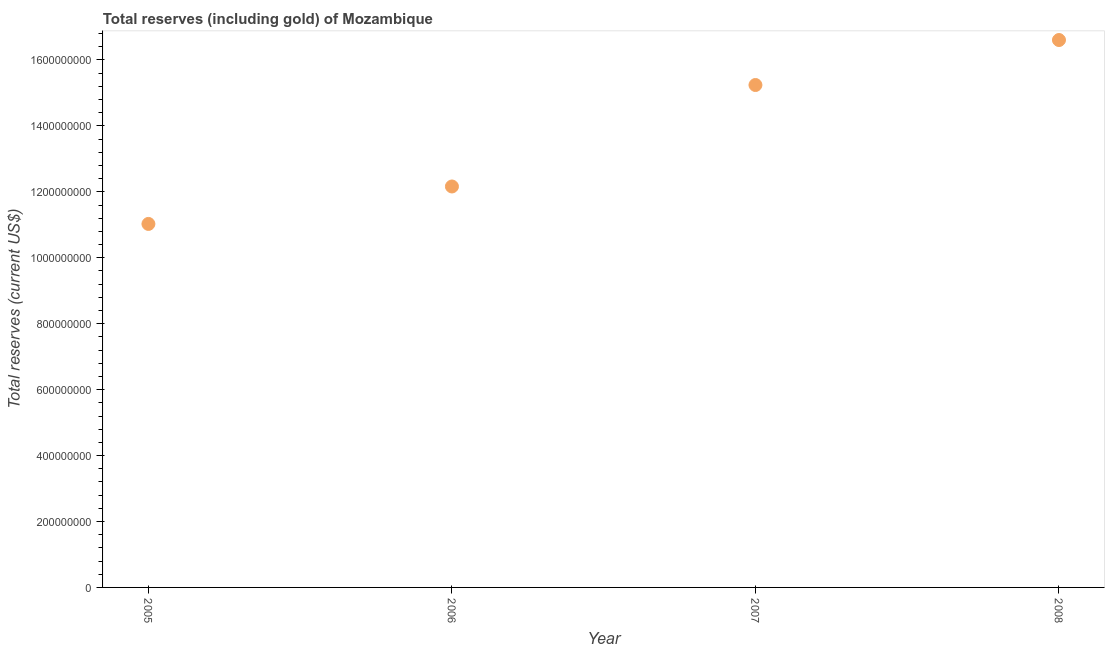What is the total reserves (including gold) in 2005?
Offer a very short reply. 1.10e+09. Across all years, what is the maximum total reserves (including gold)?
Your answer should be compact. 1.66e+09. Across all years, what is the minimum total reserves (including gold)?
Your answer should be compact. 1.10e+09. What is the sum of the total reserves (including gold)?
Provide a short and direct response. 5.50e+09. What is the difference between the total reserves (including gold) in 2005 and 2007?
Offer a terse response. -4.21e+08. What is the average total reserves (including gold) per year?
Your response must be concise. 1.38e+09. What is the median total reserves (including gold)?
Keep it short and to the point. 1.37e+09. What is the ratio of the total reserves (including gold) in 2005 to that in 2007?
Ensure brevity in your answer.  0.72. What is the difference between the highest and the second highest total reserves (including gold)?
Make the answer very short. 1.36e+08. Is the sum of the total reserves (including gold) in 2005 and 2006 greater than the maximum total reserves (including gold) across all years?
Offer a very short reply. Yes. What is the difference between the highest and the lowest total reserves (including gold)?
Provide a succinct answer. 5.58e+08. How many dotlines are there?
Make the answer very short. 1. What is the difference between two consecutive major ticks on the Y-axis?
Give a very brief answer. 2.00e+08. Does the graph contain any zero values?
Offer a very short reply. No. Does the graph contain grids?
Your answer should be very brief. No. What is the title of the graph?
Offer a very short reply. Total reserves (including gold) of Mozambique. What is the label or title of the Y-axis?
Offer a very short reply. Total reserves (current US$). What is the Total reserves (current US$) in 2005?
Keep it short and to the point. 1.10e+09. What is the Total reserves (current US$) in 2006?
Offer a terse response. 1.22e+09. What is the Total reserves (current US$) in 2007?
Provide a short and direct response. 1.52e+09. What is the Total reserves (current US$) in 2008?
Your answer should be compact. 1.66e+09. What is the difference between the Total reserves (current US$) in 2005 and 2006?
Your response must be concise. -1.14e+08. What is the difference between the Total reserves (current US$) in 2005 and 2007?
Give a very brief answer. -4.21e+08. What is the difference between the Total reserves (current US$) in 2005 and 2008?
Provide a succinct answer. -5.58e+08. What is the difference between the Total reserves (current US$) in 2006 and 2007?
Offer a terse response. -3.08e+08. What is the difference between the Total reserves (current US$) in 2006 and 2008?
Give a very brief answer. -4.44e+08. What is the difference between the Total reserves (current US$) in 2007 and 2008?
Keep it short and to the point. -1.36e+08. What is the ratio of the Total reserves (current US$) in 2005 to that in 2006?
Your answer should be very brief. 0.91. What is the ratio of the Total reserves (current US$) in 2005 to that in 2007?
Keep it short and to the point. 0.72. What is the ratio of the Total reserves (current US$) in 2005 to that in 2008?
Your response must be concise. 0.66. What is the ratio of the Total reserves (current US$) in 2006 to that in 2007?
Provide a succinct answer. 0.8. What is the ratio of the Total reserves (current US$) in 2006 to that in 2008?
Offer a terse response. 0.73. What is the ratio of the Total reserves (current US$) in 2007 to that in 2008?
Give a very brief answer. 0.92. 